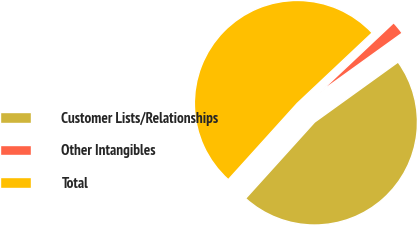Convert chart. <chart><loc_0><loc_0><loc_500><loc_500><pie_chart><fcel>Customer Lists/Relationships<fcel>Other Intangibles<fcel>Total<nl><fcel>46.62%<fcel>2.09%<fcel>51.28%<nl></chart> 